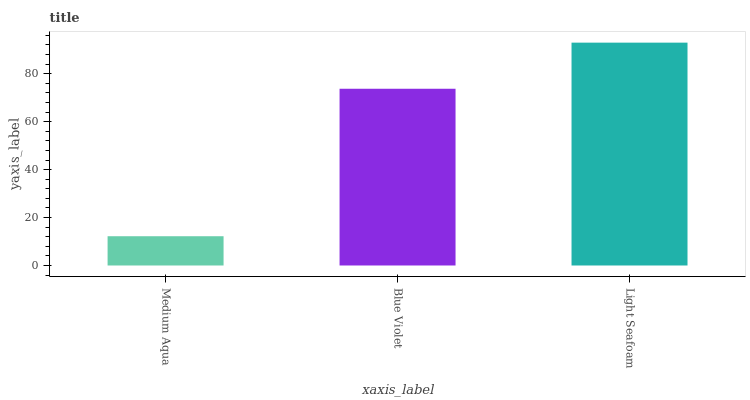Is Blue Violet the minimum?
Answer yes or no. No. Is Blue Violet the maximum?
Answer yes or no. No. Is Blue Violet greater than Medium Aqua?
Answer yes or no. Yes. Is Medium Aqua less than Blue Violet?
Answer yes or no. Yes. Is Medium Aqua greater than Blue Violet?
Answer yes or no. No. Is Blue Violet less than Medium Aqua?
Answer yes or no. No. Is Blue Violet the high median?
Answer yes or no. Yes. Is Blue Violet the low median?
Answer yes or no. Yes. Is Light Seafoam the high median?
Answer yes or no. No. Is Medium Aqua the low median?
Answer yes or no. No. 